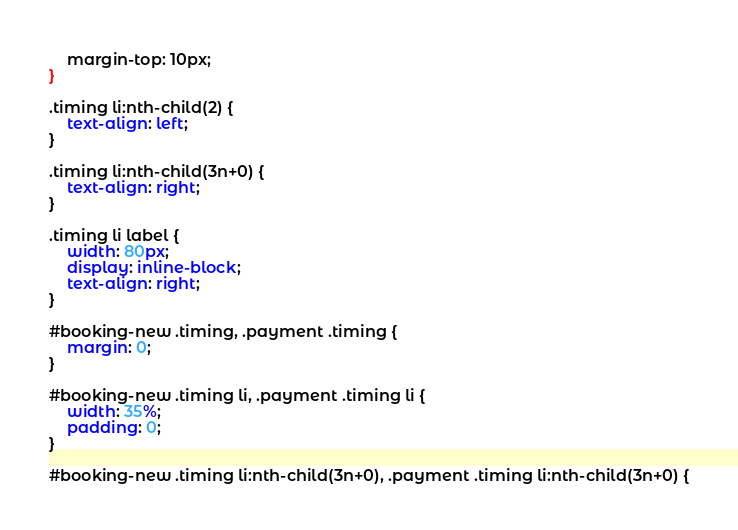<code> <loc_0><loc_0><loc_500><loc_500><_CSS_>    margin-top: 10px;
}

.timing li:nth-child(2) {
    text-align: left;
}

.timing li:nth-child(3n+0) {
    text-align: right;
}

.timing li label {
    width: 80px;
    display: inline-block;
    text-align: right;
}

#booking-new .timing, .payment .timing {
    margin: 0;
}

#booking-new .timing li, .payment .timing li {
    width: 35%;
    padding: 0;
}

#booking-new .timing li:nth-child(3n+0), .payment .timing li:nth-child(3n+0) {</code> 